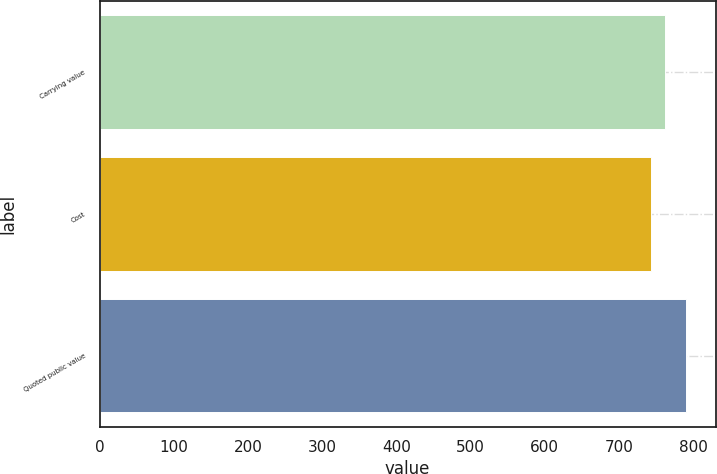Convert chart. <chart><loc_0><loc_0><loc_500><loc_500><bar_chart><fcel>Carrying value<fcel>Cost<fcel>Quoted public value<nl><fcel>762<fcel>743<fcel>791<nl></chart> 